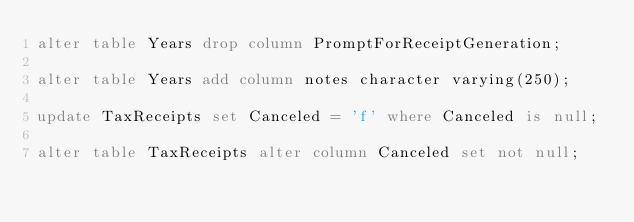<code> <loc_0><loc_0><loc_500><loc_500><_SQL_>alter table Years drop column PromptForReceiptGeneration;

alter table Years add column notes character varying(250);

update TaxReceipts set Canceled = 'f' where Canceled is null;

alter table TaxReceipts alter column Canceled set not null;

</code> 